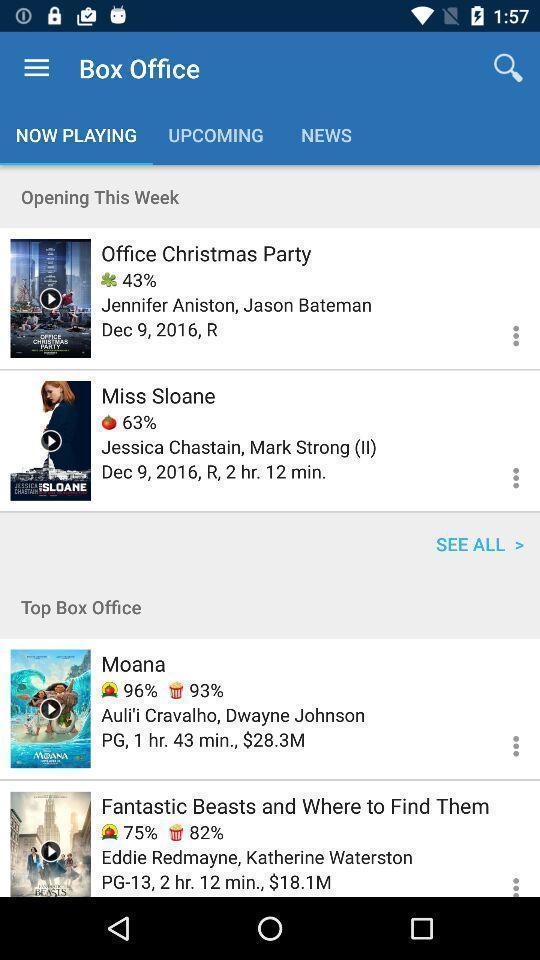What details can you identify in this image? Social app showing list of box office. 